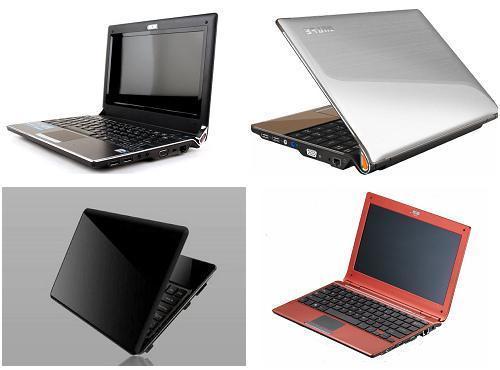How many computers?
Give a very brief answer. 4. How many laptops are in the photo?
Give a very brief answer. 4. How many motorcycles in the picture?
Give a very brief answer. 0. 